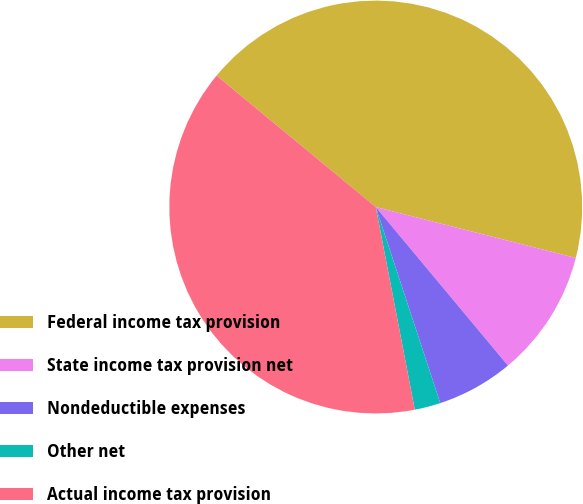Convert chart. <chart><loc_0><loc_0><loc_500><loc_500><pie_chart><fcel>Federal income tax provision<fcel>State income tax provision net<fcel>Nondeductible expenses<fcel>Other net<fcel>Actual income tax provision<nl><fcel>42.98%<fcel>9.97%<fcel>6.0%<fcel>2.03%<fcel>39.01%<nl></chart> 